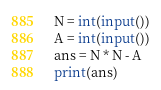<code> <loc_0><loc_0><loc_500><loc_500><_Python_>N = int(input())
A = int(input())
ans = N * N - A
print(ans)</code> 